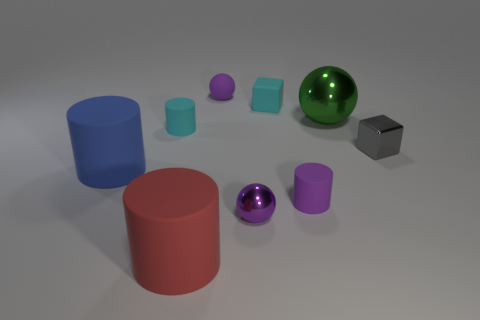Are there any matte cubes of the same size as the green thing?
Make the answer very short. No. Are there fewer cylinders on the left side of the big blue rubber cylinder than green metal balls?
Your answer should be very brief. Yes. The cyan object in front of the small cyan matte thing right of the purple ball that is behind the blue object is made of what material?
Your response must be concise. Rubber. Is the number of metal spheres that are behind the purple metallic thing greater than the number of big red matte cylinders to the right of the small purple rubber sphere?
Offer a very short reply. Yes. What number of shiny objects are purple cylinders or cyan blocks?
Provide a succinct answer. 0. What shape is the small metallic thing that is the same color as the matte ball?
Offer a terse response. Sphere. What is the material of the tiny cyan thing in front of the big green metal object?
Make the answer very short. Rubber. How many objects are either tiny gray shiny cubes or small spheres that are in front of the big metallic sphere?
Give a very brief answer. 2. What is the shape of the blue object that is the same size as the green ball?
Your answer should be compact. Cylinder. What number of big metal things are the same color as the matte block?
Your answer should be very brief. 0. 